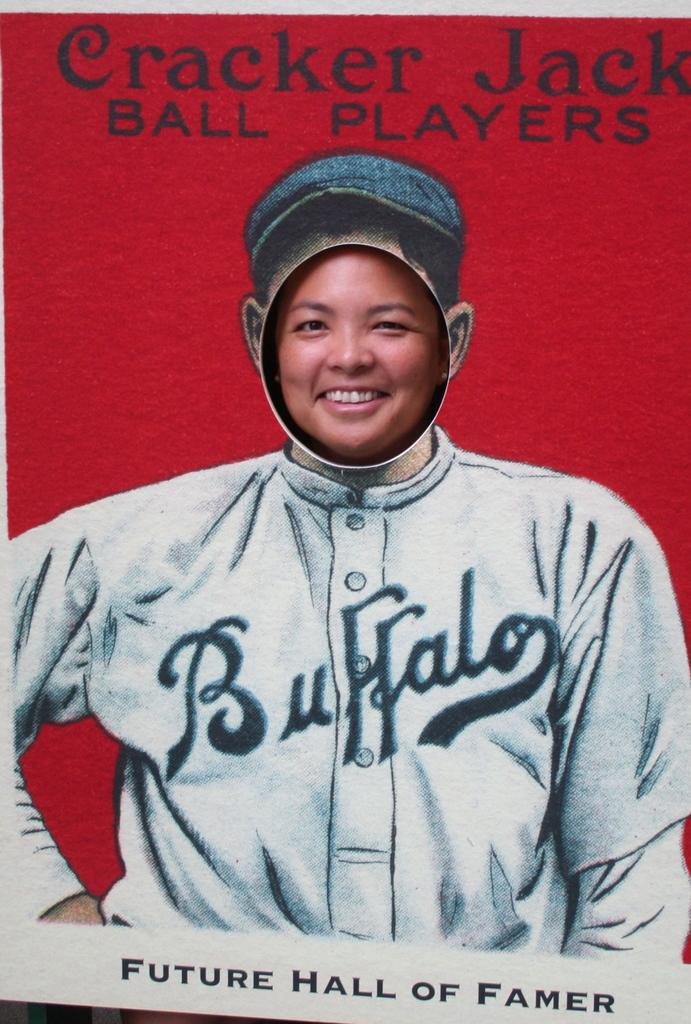What type of visual is the image? The image is a poster. What is the person in the poster doing? There is a person smiling in the poster. What else can be found on the poster besides the image? There is text present in the poster. What type of quill is the person holding in the poster? There is no quill present in the poster; the person is simply smiling. Can you tell me how many clubs are visible in the poster? There are no clubs visible in the poster; it only features a person smiling and text. 